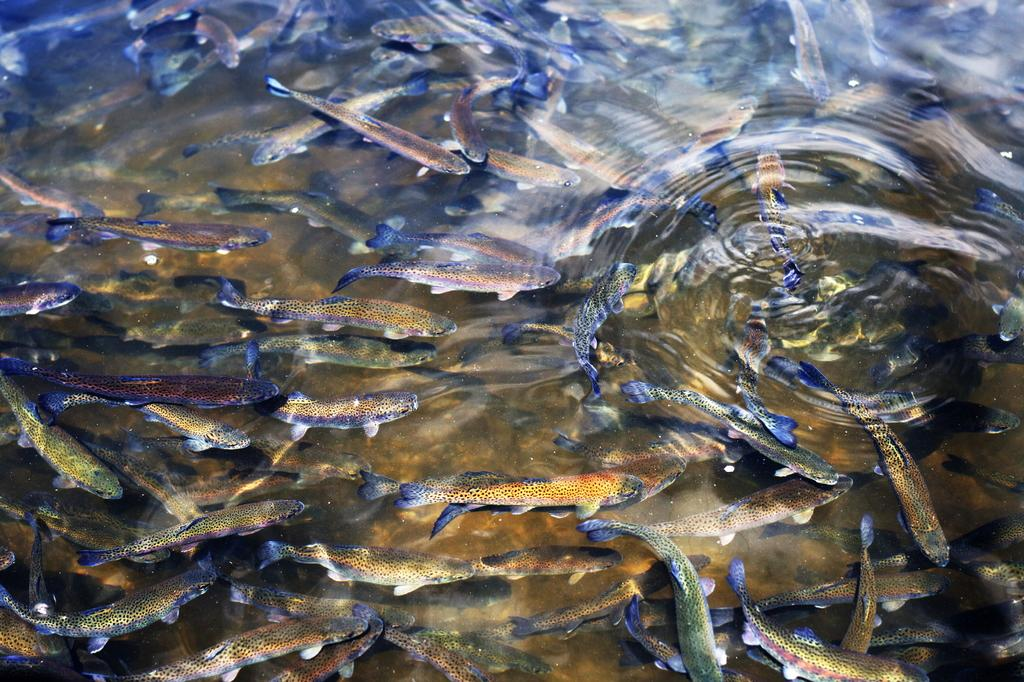What type of animals can be seen in the water in the image? There are fishes in the water in the image. What is the condition of the water's surface? The water has ripples on its surface. What can be observed about the appearance of the fishes? The fishes are of different colors. What is the name of the spy who is hiding under the water in the image? There is no spy present in the image; it features fishes in the water. What type of chin can be seen on the fishes in the image? Fishes do not have chins, so this detail cannot be observed in the image. 